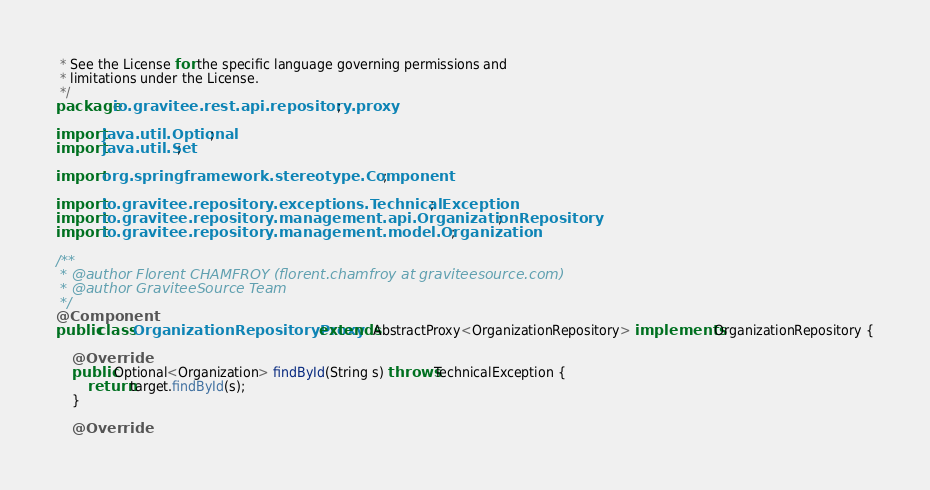<code> <loc_0><loc_0><loc_500><loc_500><_Java_> * See the License for the specific language governing permissions and
 * limitations under the License.
 */
package io.gravitee.rest.api.repository.proxy;

import java.util.Optional;
import java.util.Set;

import org.springframework.stereotype.Component;

import io.gravitee.repository.exceptions.TechnicalException;
import io.gravitee.repository.management.api.OrganizationRepository;
import io.gravitee.repository.management.model.Organization;

/**
 * @author Florent CHAMFROY (florent.chamfroy at graviteesource.com)
 * @author GraviteeSource Team
 */
@Component
public class OrganizationRepositoryProxy extends AbstractProxy<OrganizationRepository> implements OrganizationRepository {

    @Override
    public Optional<Organization> findById(String s) throws TechnicalException {
        return target.findById(s);
    }

    @Override</code> 